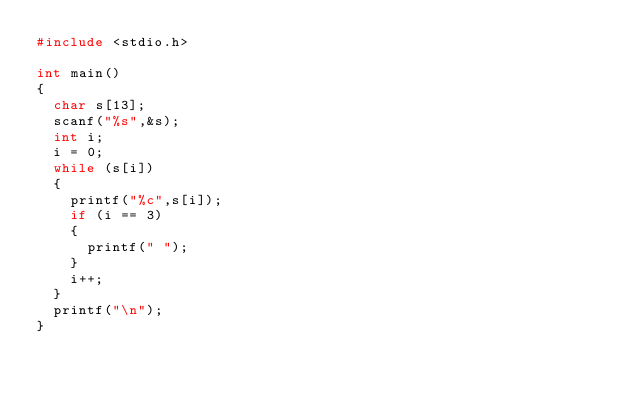Convert code to text. <code><loc_0><loc_0><loc_500><loc_500><_C_>#include <stdio.h>
 
int main()
{
  char s[13];
  scanf("%s",&s);
  int i;
  i = 0;
  while (s[i])
  {
    printf("%c",s[i]);
    if (i == 3)
    {
      printf(" ");
    }
    i++;
  }
  printf("\n");
}</code> 